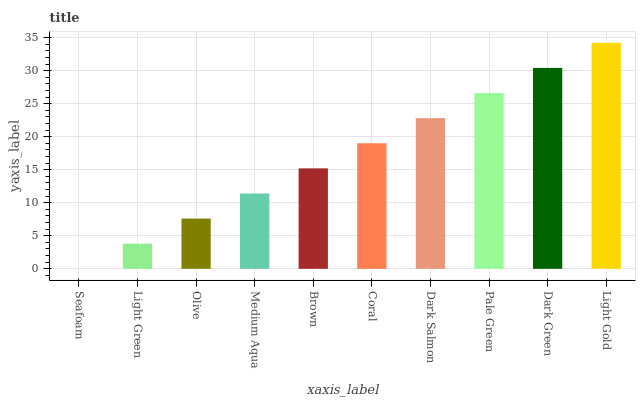Is Seafoam the minimum?
Answer yes or no. Yes. Is Light Gold the maximum?
Answer yes or no. Yes. Is Light Green the minimum?
Answer yes or no. No. Is Light Green the maximum?
Answer yes or no. No. Is Light Green greater than Seafoam?
Answer yes or no. Yes. Is Seafoam less than Light Green?
Answer yes or no. Yes. Is Seafoam greater than Light Green?
Answer yes or no. No. Is Light Green less than Seafoam?
Answer yes or no. No. Is Coral the high median?
Answer yes or no. Yes. Is Brown the low median?
Answer yes or no. Yes. Is Light Gold the high median?
Answer yes or no. No. Is Pale Green the low median?
Answer yes or no. No. 